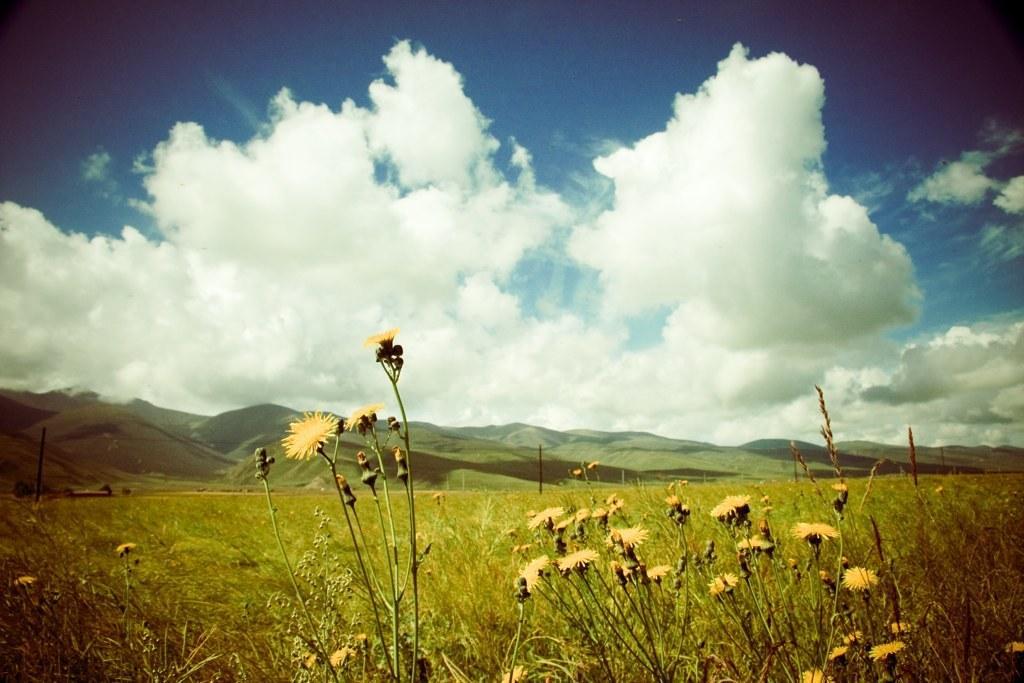How would you summarize this image in a sentence or two? At the bottom of this image, we can see there are plants having flowers. In the background, there are mountains and there are clouds in the blue sky. 